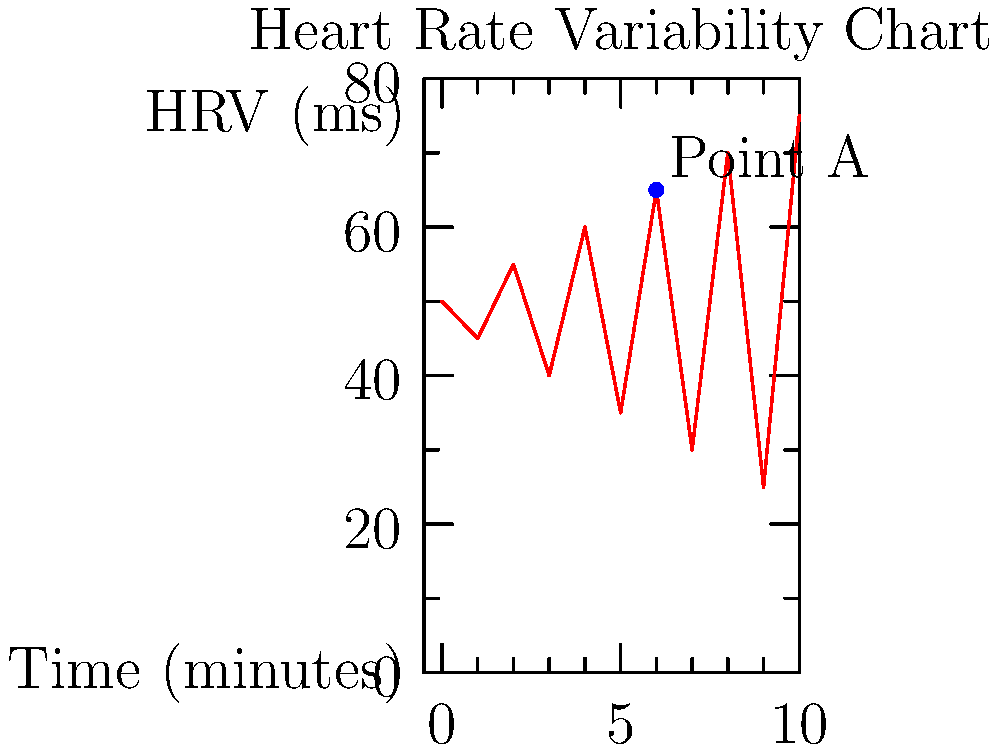As a novelist incorporating psychiatric observations into character development, you're analyzing a heart rate variability (HRV) chart to gauge a character's stress levels. The chart shows HRV measurements over 10 minutes. At Point A, what does the sharp increase in HRV likely indicate about the character's psychological state, and how might this inform your character's narrative arc? To answer this question, let's break down the analysis of the HRV chart:

1. Understanding HRV: Higher HRV generally indicates better stress resilience and adaptability, while lower HRV suggests increased stress or reduced capacity to cope.

2. Observing the trend: The chart shows an overall oscillating pattern with increasing amplitude over time.

3. Analyzing Point A: At the 6-minute mark (Point A), there's a sharp increase in HRV from about 35 ms to 65 ms.

4. Interpreting the increase: A sudden increase in HRV often indicates:
   a) A shift from a stressful state to a more relaxed state
   b) The activation of the parasympathetic nervous system
   c) Improved emotional regulation or coping mechanism

5. Character implications:
   a) The character may have just overcome a stressful situation
   b) They might have employed a successful coping strategy (e.g., deep breathing, positive thinking)
   c) An external factor may have suddenly alleviated their stress

6. Narrative arc considerations:
   a) This could mark a turning point in the character's emotional journey
   b) It might represent a moment of clarity or decision-making
   c) The event causing this change could be a pivotal plot point

7. Further development:
   a) Consider what led to this sudden change
   b) Explore how this newfound resilience affects subsequent events
   c) Examine if this pattern repeats or if it's a one-time occurrence

In crafting the character's arc, this moment of increased HRV could represent a significant shift in their ability to handle stress, potentially influencing their decisions and interactions in the story moving forward.
Answer: Sudden stress relief or successful coping, marking a potential turning point in the character's emotional journey and narrative arc. 